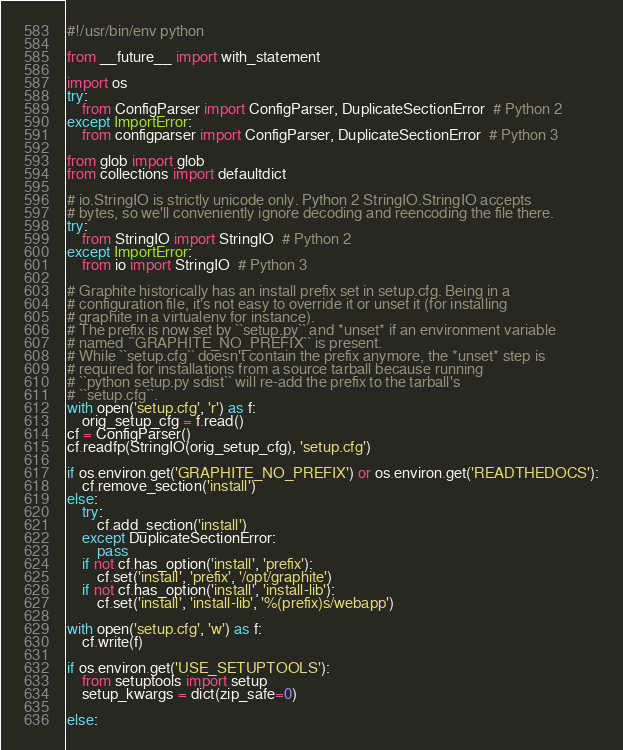Convert code to text. <code><loc_0><loc_0><loc_500><loc_500><_Python_>#!/usr/bin/env python

from __future__ import with_statement

import os
try:
    from ConfigParser import ConfigParser, DuplicateSectionError  # Python 2
except ImportError:
    from configparser import ConfigParser, DuplicateSectionError  # Python 3

from glob import glob
from collections import defaultdict

# io.StringIO is strictly unicode only. Python 2 StringIO.StringIO accepts
# bytes, so we'll conveniently ignore decoding and reencoding the file there.
try:
    from StringIO import StringIO  # Python 2
except ImportError:
    from io import StringIO  # Python 3

# Graphite historically has an install prefix set in setup.cfg. Being in a
# configuration file, it's not easy to override it or unset it (for installing
# graphite in a virtualenv for instance).
# The prefix is now set by ``setup.py`` and *unset* if an environment variable
# named ``GRAPHITE_NO_PREFIX`` is present.
# While ``setup.cfg`` doesn't contain the prefix anymore, the *unset* step is
# required for installations from a source tarball because running
# ``python setup.py sdist`` will re-add the prefix to the tarball's
# ``setup.cfg``.
with open('setup.cfg', 'r') as f:
    orig_setup_cfg = f.read()
cf = ConfigParser()
cf.readfp(StringIO(orig_setup_cfg), 'setup.cfg')

if os.environ.get('GRAPHITE_NO_PREFIX') or os.environ.get('READTHEDOCS'):
    cf.remove_section('install')
else:
    try:
        cf.add_section('install')
    except DuplicateSectionError:
        pass
    if not cf.has_option('install', 'prefix'):
        cf.set('install', 'prefix', '/opt/graphite')
    if not cf.has_option('install', 'install-lib'):
        cf.set('install', 'install-lib', '%(prefix)s/webapp')

with open('setup.cfg', 'w') as f:
    cf.write(f)

if os.environ.get('USE_SETUPTOOLS'):
    from setuptools import setup
    setup_kwargs = dict(zip_safe=0)

else:</code> 